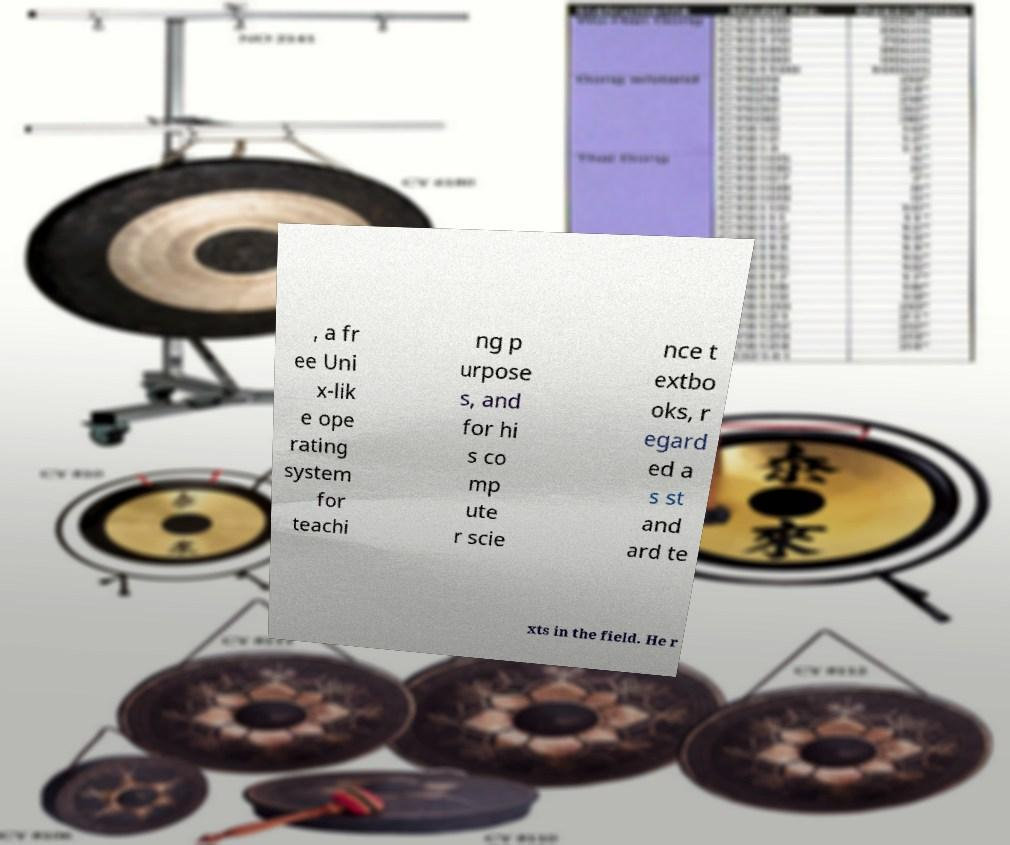Can you read and provide the text displayed in the image?This photo seems to have some interesting text. Can you extract and type it out for me? , a fr ee Uni x-lik e ope rating system for teachi ng p urpose s, and for hi s co mp ute r scie nce t extbo oks, r egard ed a s st and ard te xts in the field. He r 